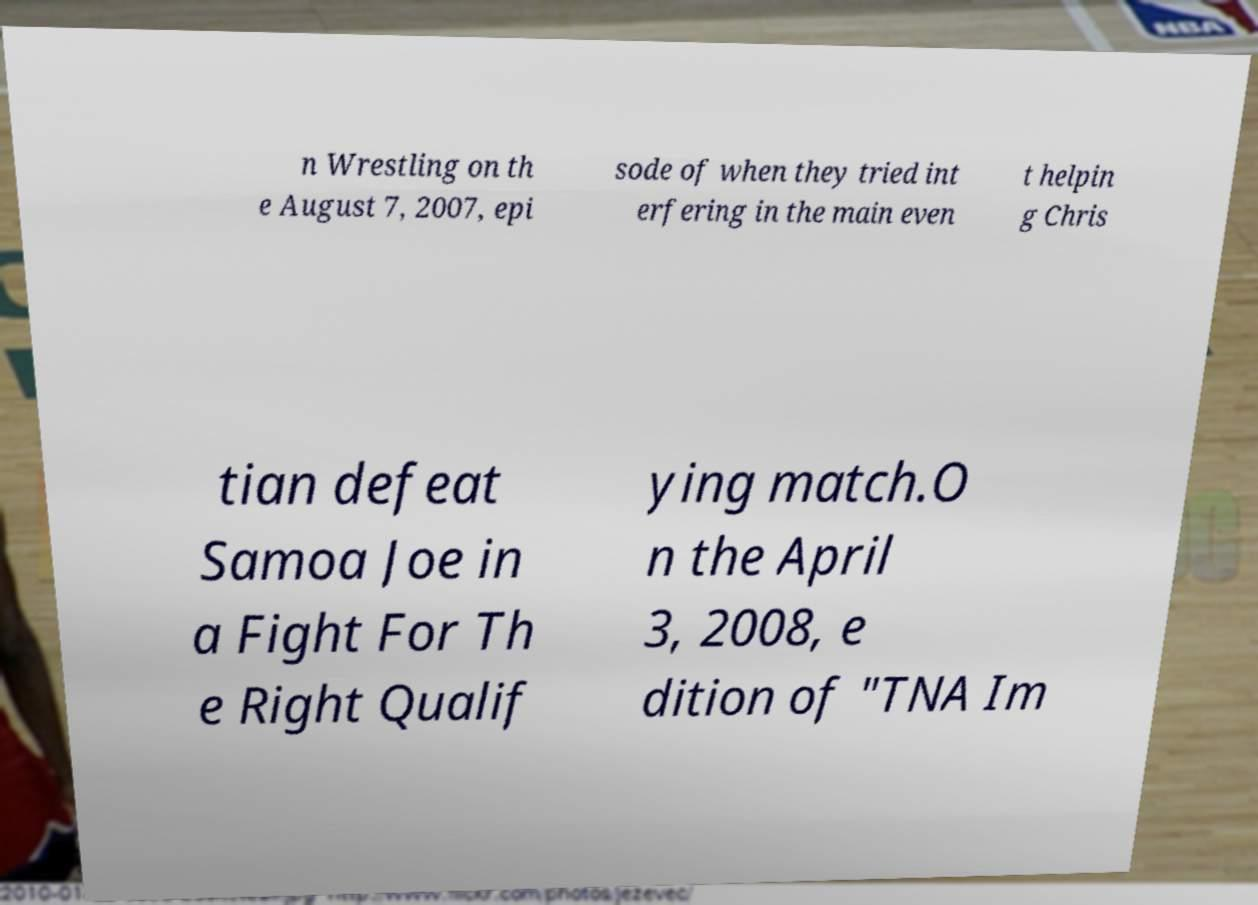Could you extract and type out the text from this image? n Wrestling on th e August 7, 2007, epi sode of when they tried int erfering in the main even t helpin g Chris tian defeat Samoa Joe in a Fight For Th e Right Qualif ying match.O n the April 3, 2008, e dition of "TNA Im 